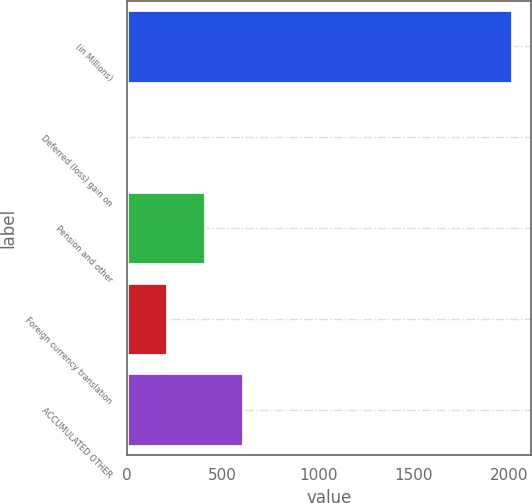<chart> <loc_0><loc_0><loc_500><loc_500><bar_chart><fcel>(in Millions)<fcel>Deferred (loss) gain on<fcel>Pension and other<fcel>Foreign currency translation<fcel>ACCUMULATED OTHER<nl><fcel>2011<fcel>7.2<fcel>407.96<fcel>207.58<fcel>608.34<nl></chart> 